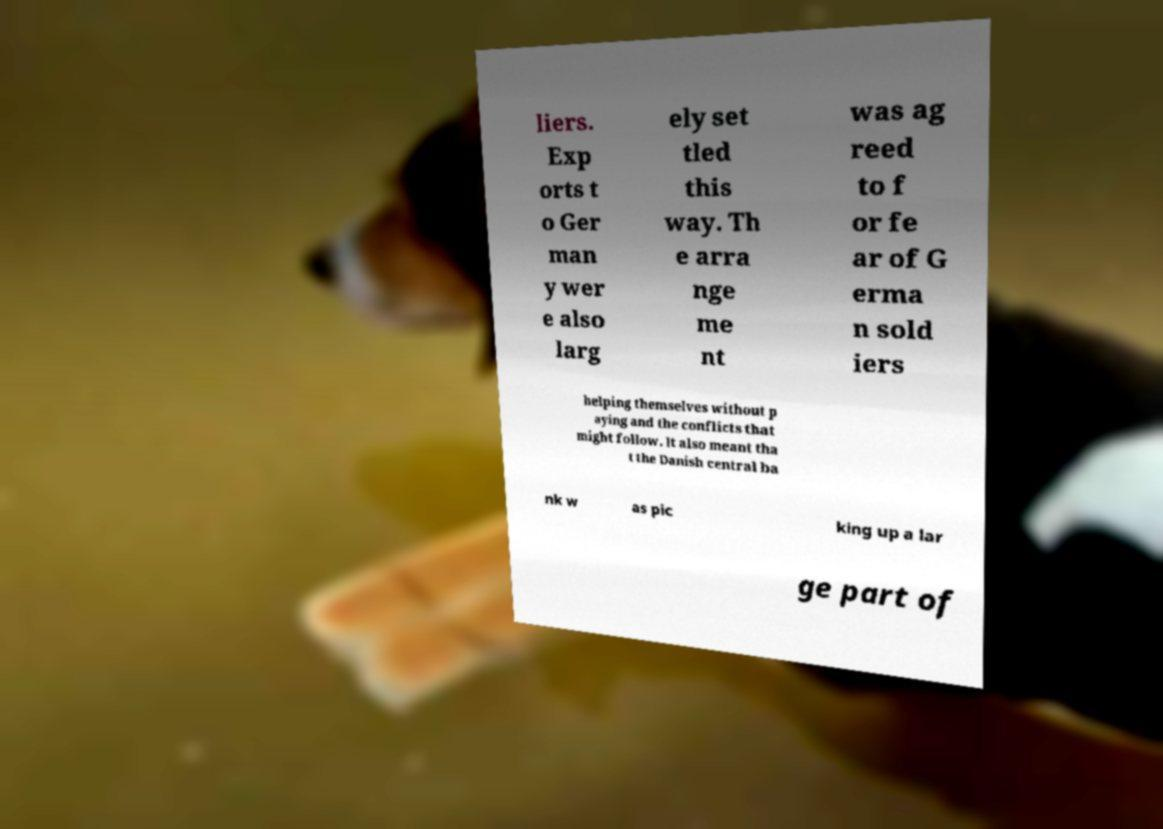Please read and relay the text visible in this image. What does it say? liers. Exp orts t o Ger man y wer e also larg ely set tled this way. Th e arra nge me nt was ag reed to f or fe ar of G erma n sold iers helping themselves without p aying and the conflicts that might follow. It also meant tha t the Danish central ba nk w as pic king up a lar ge part of 